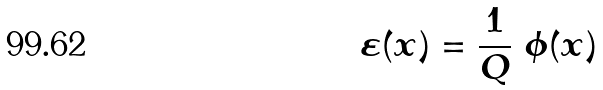Convert formula to latex. <formula><loc_0><loc_0><loc_500><loc_500>\varepsilon ( x ) = \frac { 1 } { Q } \ \phi ( x )</formula> 